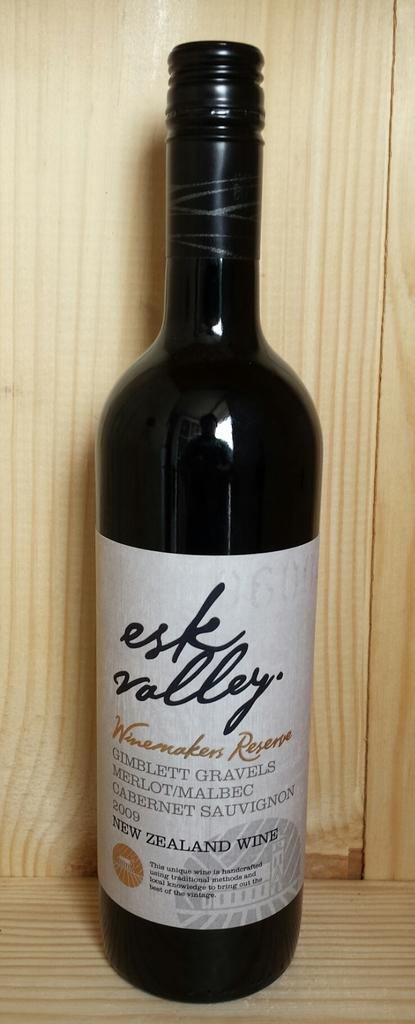What is the name of the wine?
Provide a succinct answer. Esk valley. 